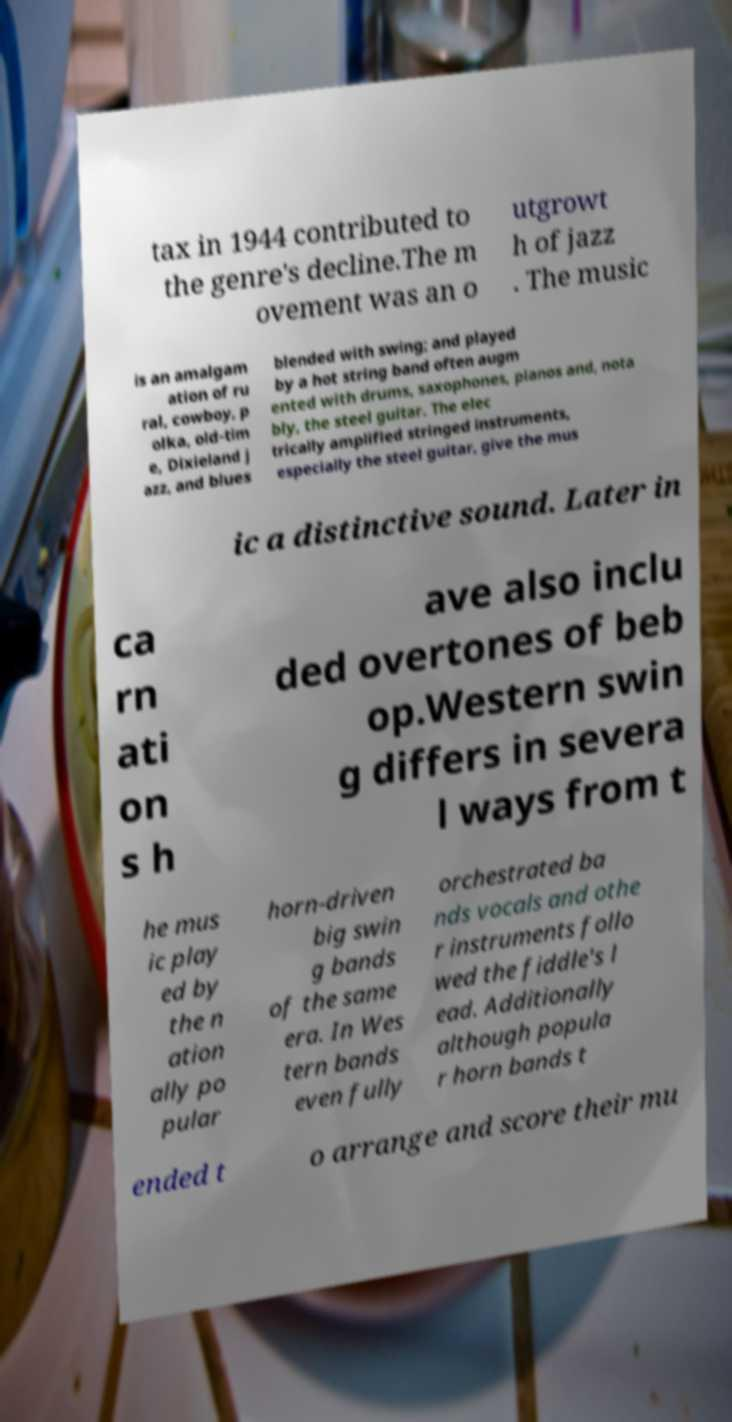There's text embedded in this image that I need extracted. Can you transcribe it verbatim? tax in 1944 contributed to the genre's decline.The m ovement was an o utgrowt h of jazz . The music is an amalgam ation of ru ral, cowboy, p olka, old-tim e, Dixieland j azz, and blues blended with swing; and played by a hot string band often augm ented with drums, saxophones, pianos and, nota bly, the steel guitar. The elec trically amplified stringed instruments, especially the steel guitar, give the mus ic a distinctive sound. Later in ca rn ati on s h ave also inclu ded overtones of beb op.Western swin g differs in severa l ways from t he mus ic play ed by the n ation ally po pular horn-driven big swin g bands of the same era. In Wes tern bands even fully orchestrated ba nds vocals and othe r instruments follo wed the fiddle's l ead. Additionally although popula r horn bands t ended t o arrange and score their mu 